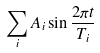Convert formula to latex. <formula><loc_0><loc_0><loc_500><loc_500>\sum _ { i } A _ { i } \sin \frac { 2 \pi t } { T _ { i } }</formula> 